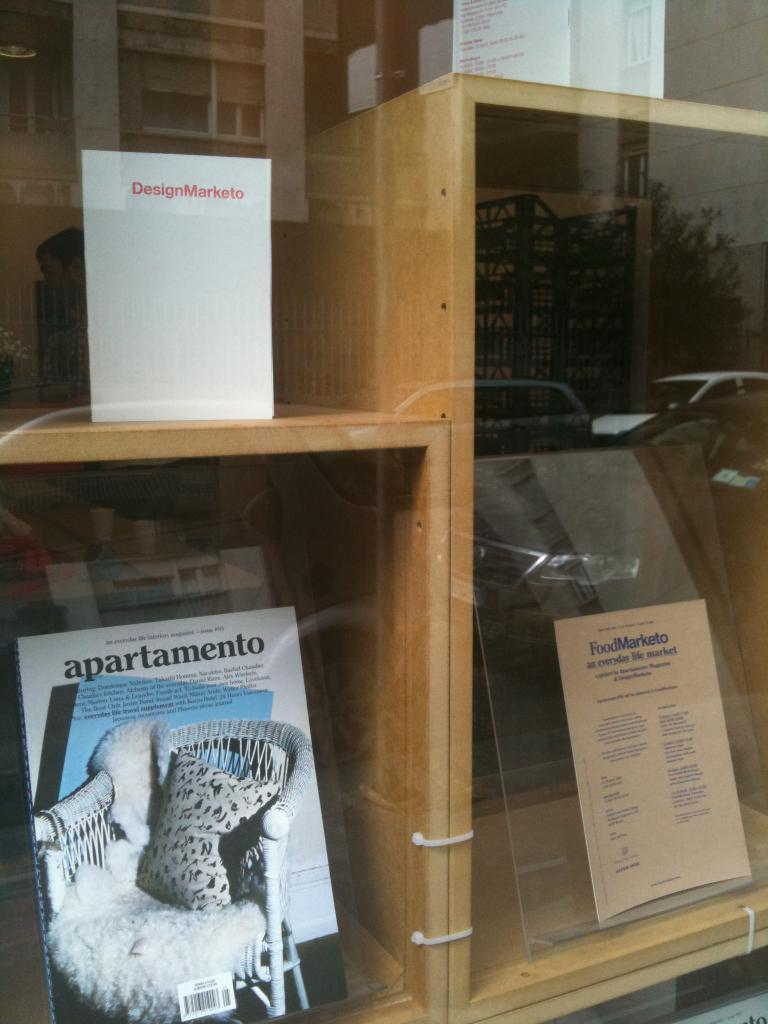How many boards are present in the wooden racks in the image? There are four boards in the wooden racks in the image. What can be seen in the reflections of the image? There is a reflection of a car, a building, a tree, and a person in the image. How many wrens are sitting on the boards in the image? There are no wrens present in the image. Are the sisters mentioned in the image? There is no mention of sisters in the image or the provided facts. 